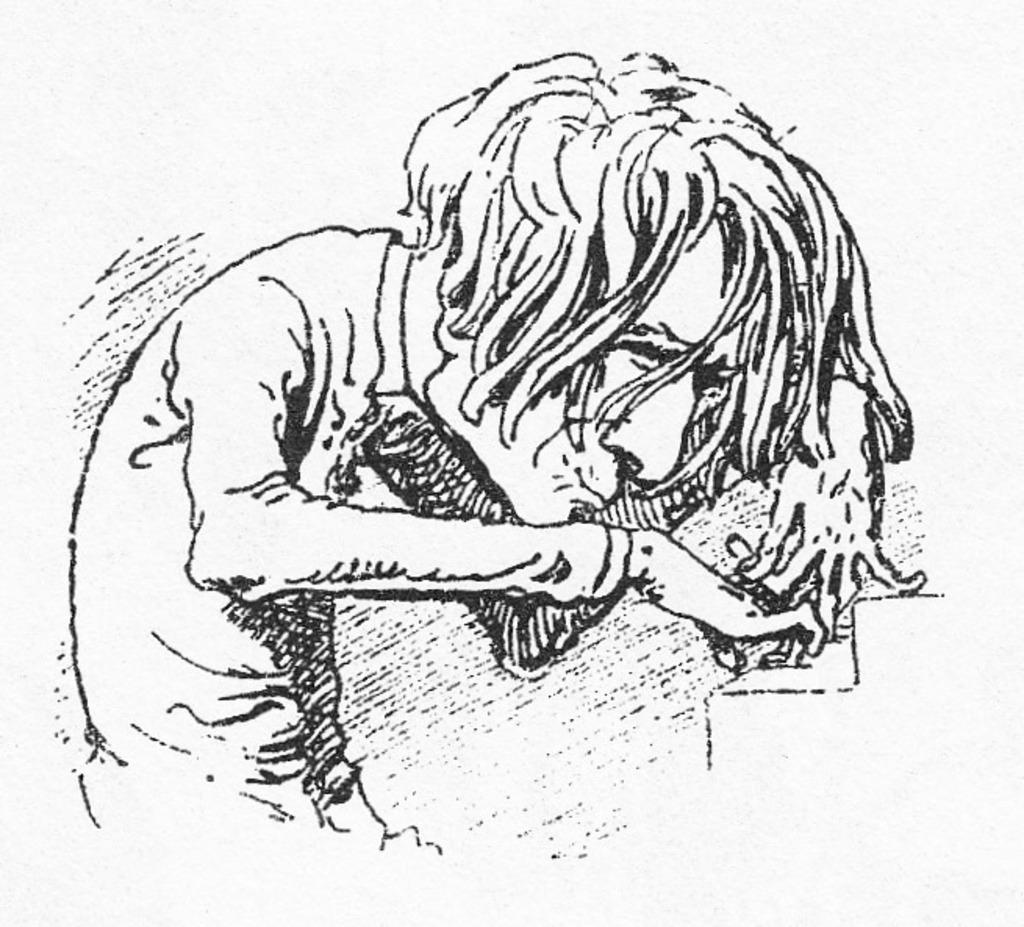What is present in the image? There is a poster in the image. What is depicted on the poster? The poster contains an art piece. What scientific experiment is being conducted in the image? There is no scientific experiment present in the image; it only contains a poster with an art piece. Can you see a game of chess being played in the image? There is no game of chess present in the image; it only contains a poster with an art piece. 